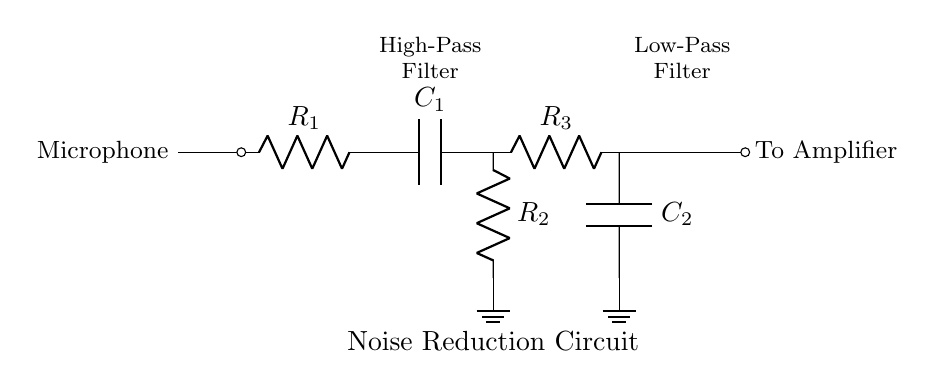What is the first component in the circuit? The first component is a microphone, which is represented at the left side of the circuit diagram and serves as the input for capturing sound.
Answer: Microphone What is the role of C1 in this circuit? C1 is part of the high-pass filter, allowing high-frequency signals to pass while blocking low-frequency noise, which is essential for reducing unwanted background sounds in voice recordings.
Answer: High-pass filter How many resistors are present in this circuit? There are three resistors in total: R1, R2, and R3, as seen in the circuit diagram, connected in different stages of filtering.
Answer: Three What does the output node connect to? The output node connects to an amplifier, which is indicated on the right side of the circuit diagram, responsible for boosting the signal after filtering.
Answer: Amplifier Why are both high-pass and low-pass filters used in this circuit? The combination of a high-pass filter (with C1 and R2) and a low-pass filter (with R3 and C2) allows the circuit to filter out both low and high-frequency noise, thus optimizing the quality of the recorded voice by emphasizing the desired frequencies in author interviews.
Answer: Noise reduction What is the function of R2 in connection with C1? R2, when combined with C1, forms the high-pass filter, which helps remove low-frequency sounds that can interfere with the clarity of the audio captured by the microphone.
Answer: High-pass filter Which component is grounded in the circuit? The component grounded in the circuit is C2, which connects to the ground symbol, serving as a reference point in the circuit to stabilize the potential difference and contribute to filtering.
Answer: C2 